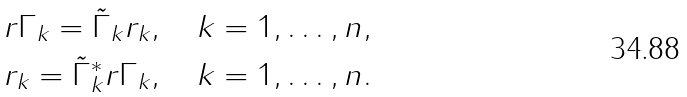<formula> <loc_0><loc_0><loc_500><loc_500>r \Gamma _ { k } = \tilde { \Gamma } _ { k } r _ { k } , \quad k = 1 , \dots , n , \\ r _ { k } = \tilde { \Gamma } _ { k } ^ { * } r \Gamma _ { k } , \quad k = 1 , \dots , n .</formula> 